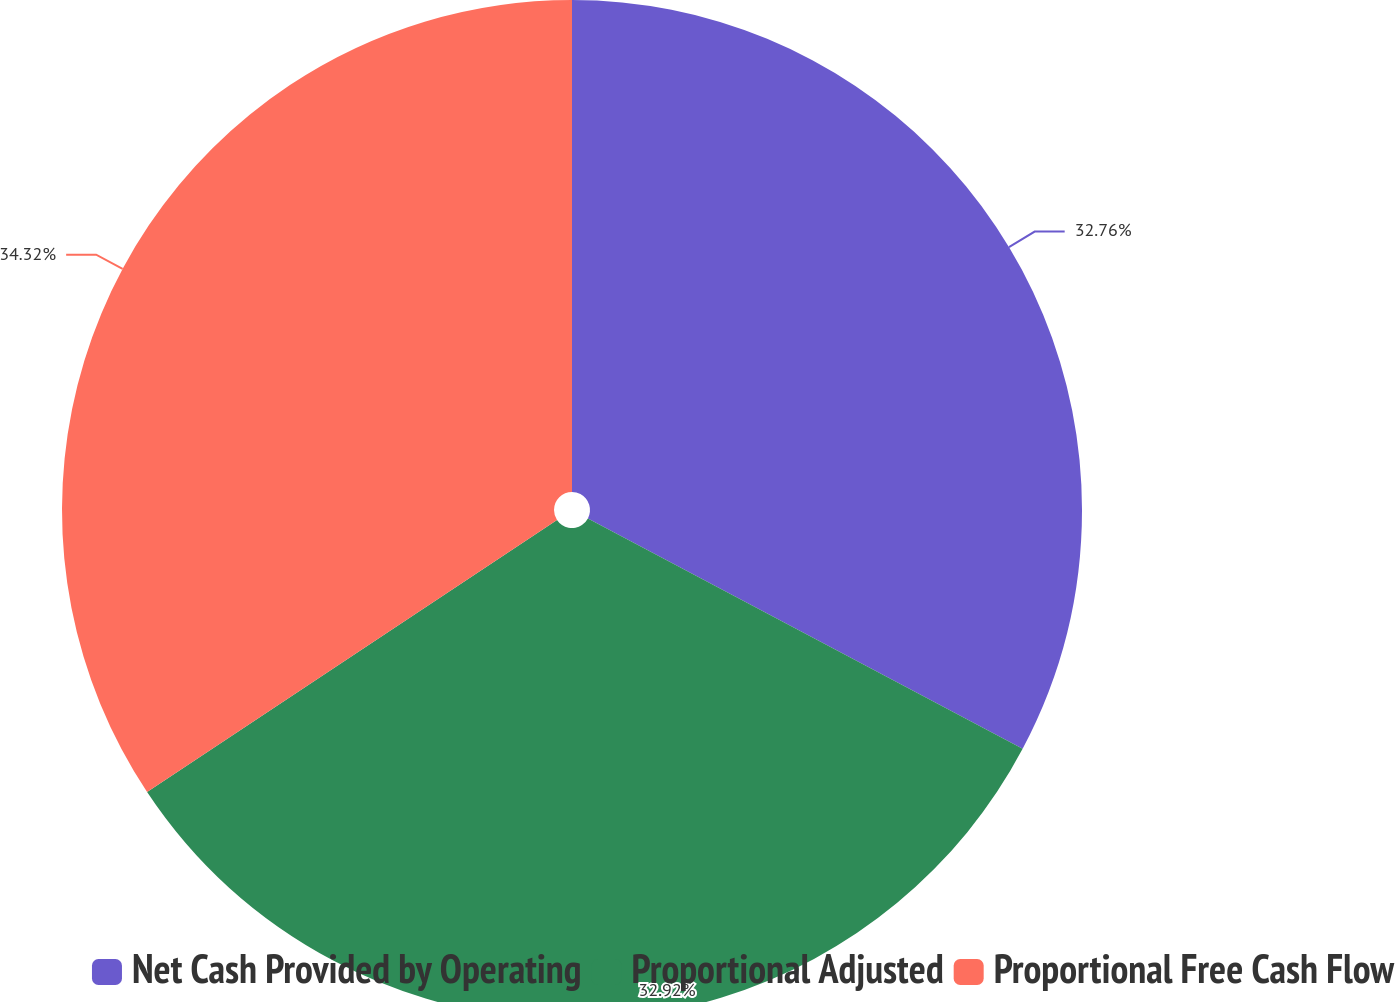Convert chart. <chart><loc_0><loc_0><loc_500><loc_500><pie_chart><fcel>Net Cash Provided by Operating<fcel>Proportional Adjusted<fcel>Proportional Free Cash Flow<nl><fcel>32.76%<fcel>32.92%<fcel>34.33%<nl></chart> 